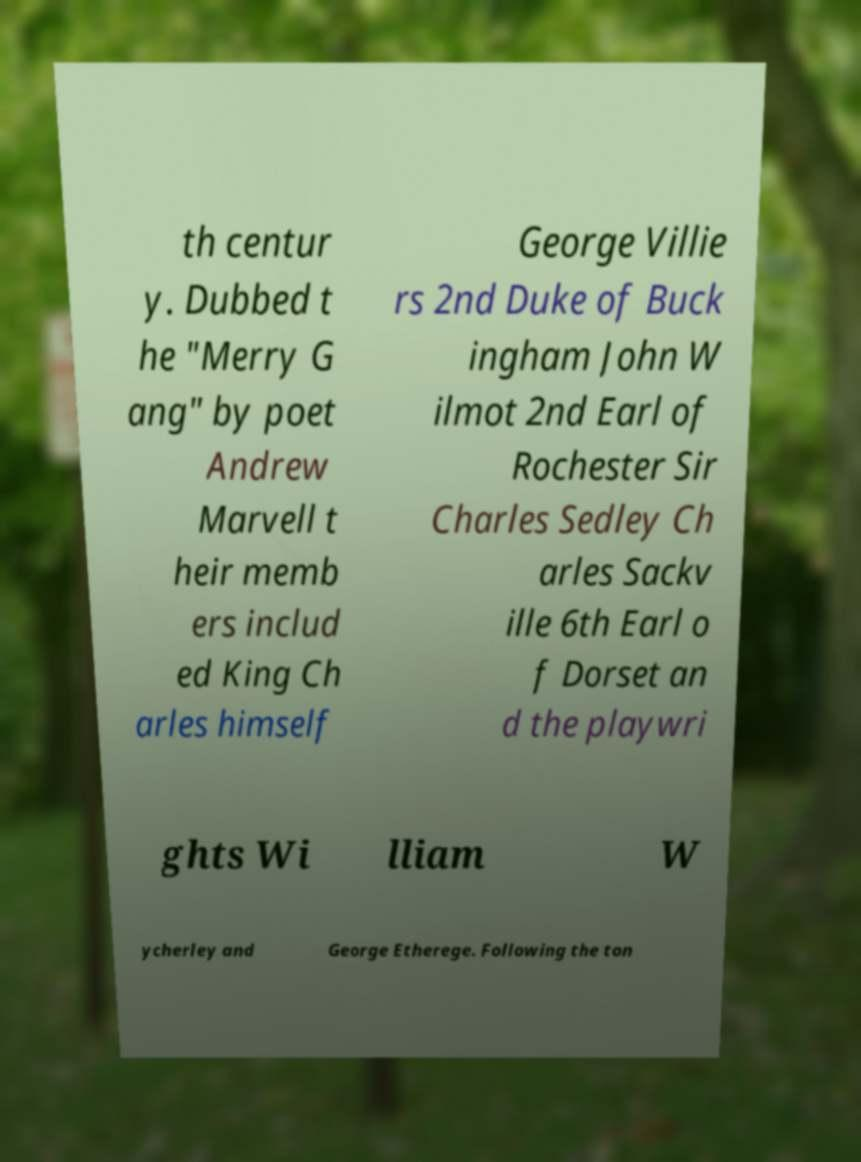For documentation purposes, I need the text within this image transcribed. Could you provide that? th centur y. Dubbed t he "Merry G ang" by poet Andrew Marvell t heir memb ers includ ed King Ch arles himself George Villie rs 2nd Duke of Buck ingham John W ilmot 2nd Earl of Rochester Sir Charles Sedley Ch arles Sackv ille 6th Earl o f Dorset an d the playwri ghts Wi lliam W ycherley and George Etherege. Following the ton 